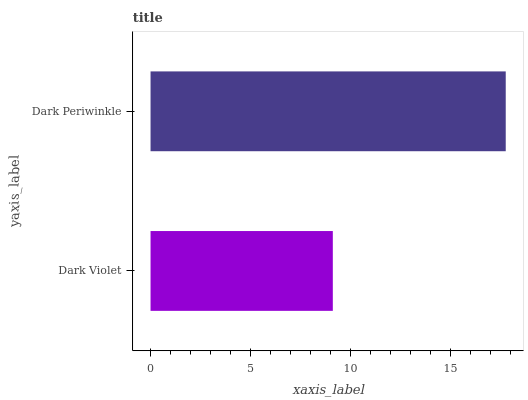Is Dark Violet the minimum?
Answer yes or no. Yes. Is Dark Periwinkle the maximum?
Answer yes or no. Yes. Is Dark Periwinkle the minimum?
Answer yes or no. No. Is Dark Periwinkle greater than Dark Violet?
Answer yes or no. Yes. Is Dark Violet less than Dark Periwinkle?
Answer yes or no. Yes. Is Dark Violet greater than Dark Periwinkle?
Answer yes or no. No. Is Dark Periwinkle less than Dark Violet?
Answer yes or no. No. Is Dark Periwinkle the high median?
Answer yes or no. Yes. Is Dark Violet the low median?
Answer yes or no. Yes. Is Dark Violet the high median?
Answer yes or no. No. Is Dark Periwinkle the low median?
Answer yes or no. No. 